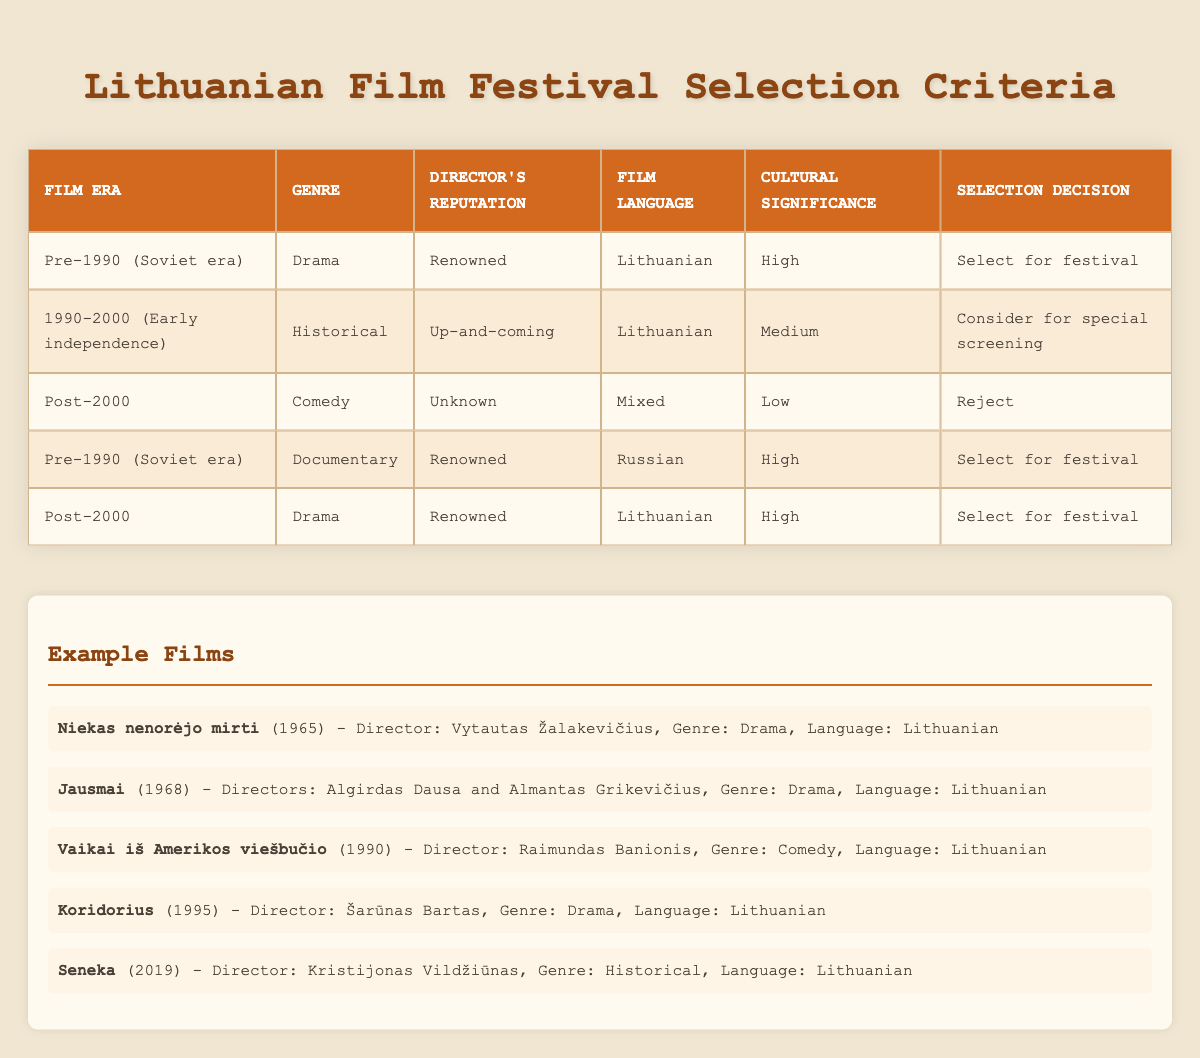What is the selection decision for a Pre-1990 Drama film with a renowned director in Lithuanian? According to the table, the conditions for selection include being from the Pre-1990 era, being in the Drama genre, having a renowned director, being in the Lithuanian language, and having high cultural significance. These criteria lead to the decision to select the film for the festival.
Answer: Select for festival Which genre of film from the Post-2000 era is rejected? The table indicates that the Post-2000 films that are comedies, have unknown directors, mixed language, and low cultural significance are the ones that get rejected. Therefore, the genre of comedy fits this criterion.
Answer: Comedy Is there any film that is selected for the festival from the 1990-2000 era? The table does not indicate any selection for the 1990-2000 era; it shows only a consideration for special screening. Therefore, the answer is no, as it is not eligible for selection for the festival.
Answer: No How many selection decisions result in rejection based on the table? The table provides one row indicating that a Post-2000 Comedy film with an unknown director and low cultural significance is rejected. This is the only instance of rejection, so there is a total of one rejection decision.
Answer: 1 If we consider films with high cultural significance, which film from the Pre-1990 era has a Lithuanian language and is directed by a renowned director? The table shows a Pre-1990 Drama film that matches these criteria. The film is a drama, Lithuanian, directed by a renowned individual, and has high cultural significance, fulfilling all specified conditions.
Answer: Select for festival What is the cultural significance of the Historical genre film in the 1990-2000 era? According to the table, the cultural significance of the Historical genre film from the 1990-2000 era is classified as medium. This indicates a moderate level of cultural relevance for this particular film.
Answer: Medium Which evaluation applies to the documentary genre produced before 1990? There is a documentary listed in the criteria table from the Pre-1990 era with high cultural significance and a renowned director, which leads to the selection decision for the festival.
Answer: Select for festival Are there any films that have a mixed language and are selected for the festival? The conditions in the table specify that a mixed language film with low cultural significance and an unknown director will be rejected. Therefore, there are no films selected for the festival under this criterion.
Answer: No 